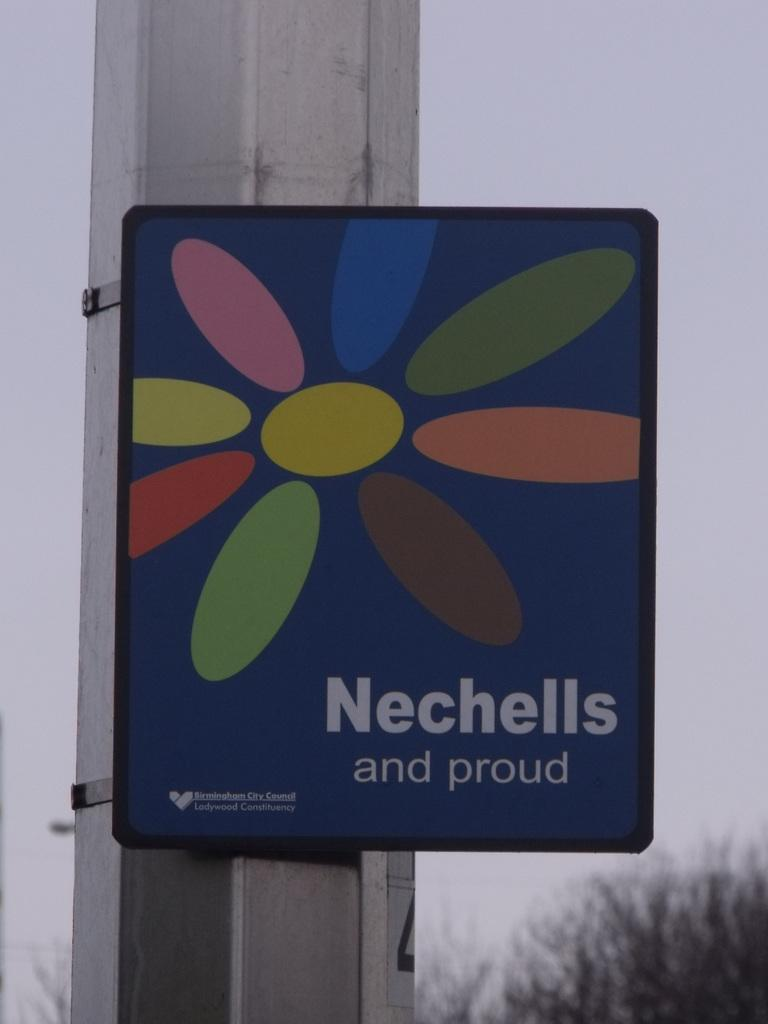<image>
Summarize the visual content of the image. Nechells and proud boarder on a pole with a heart logo. 